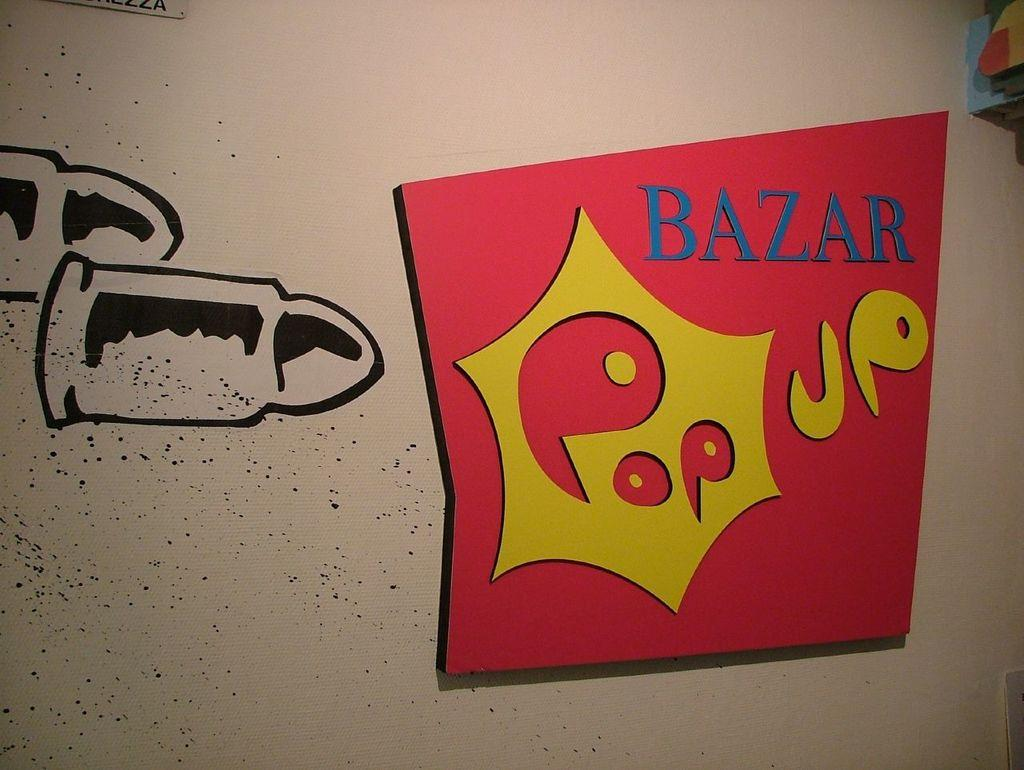<image>
Relay a brief, clear account of the picture shown. A colorful wall image of a pop up bazar. 